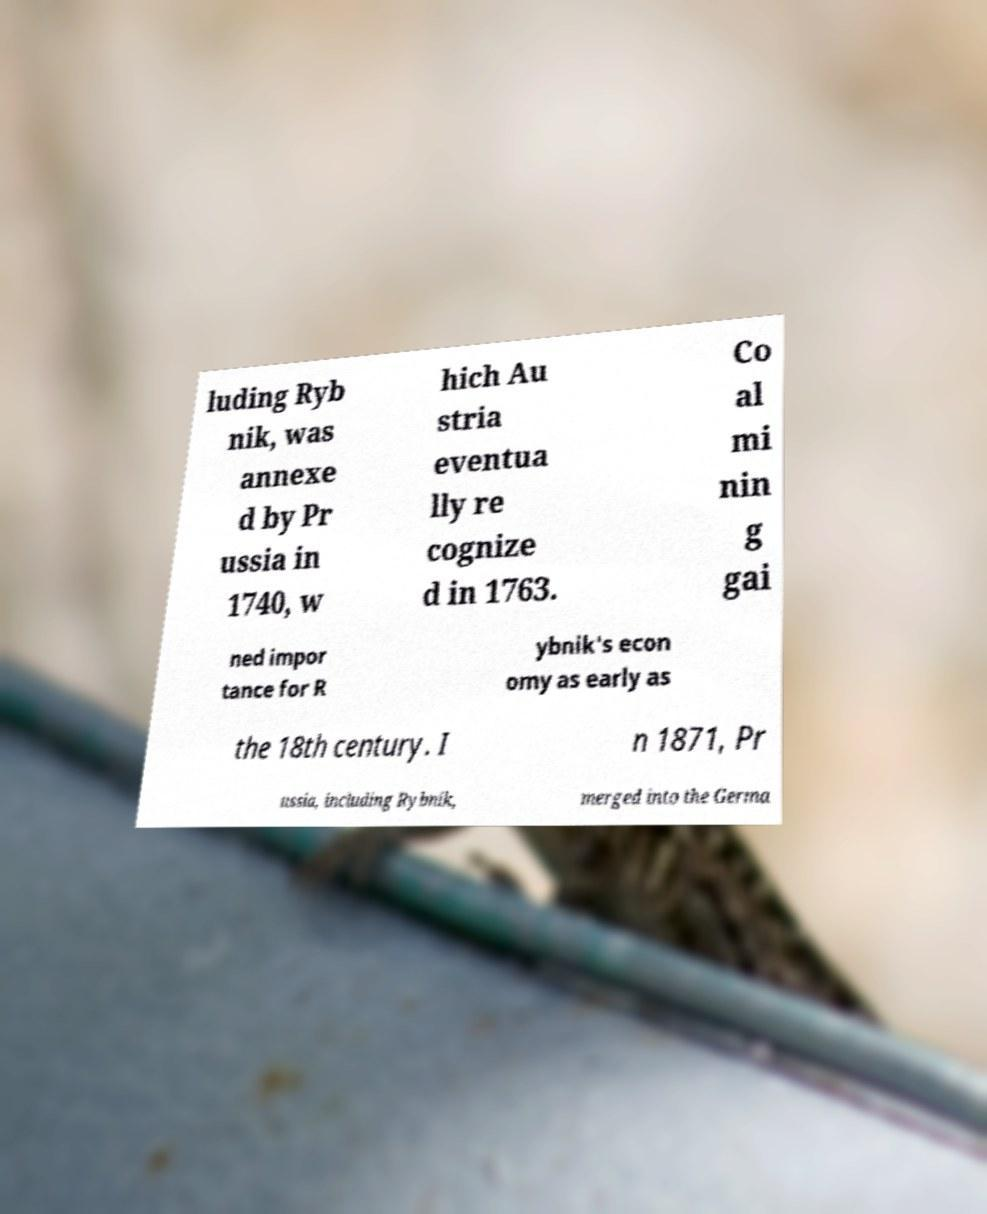Could you assist in decoding the text presented in this image and type it out clearly? luding Ryb nik, was annexe d by Pr ussia in 1740, w hich Au stria eventua lly re cognize d in 1763. Co al mi nin g gai ned impor tance for R ybnik's econ omy as early as the 18th century. I n 1871, Pr ussia, including Rybnik, merged into the Germa 